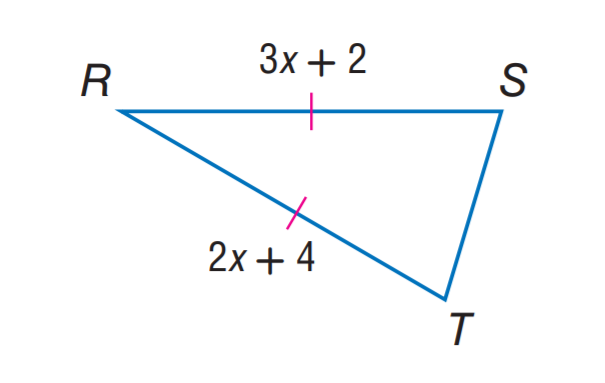Answer the mathemtical geometry problem and directly provide the correct option letter.
Question: Find R S.
Choices: A: 4 B: 6 C: 8 D: 10 C 